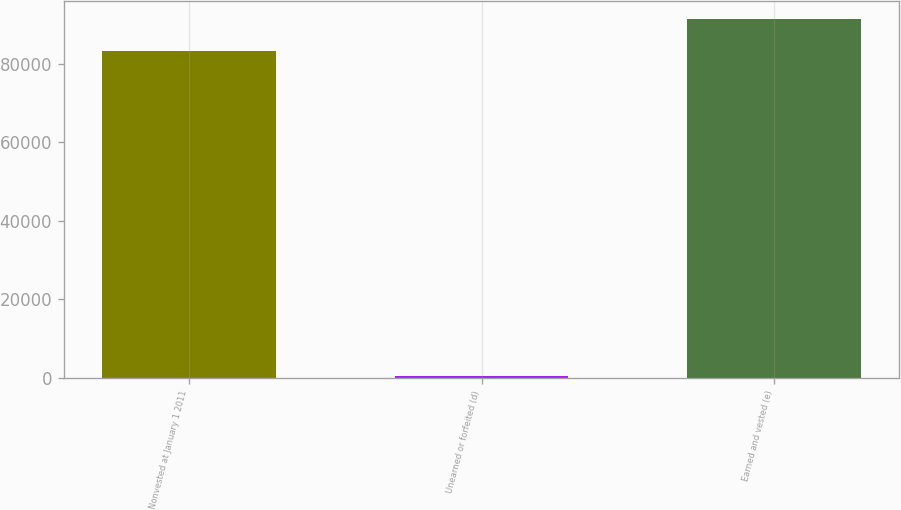Convert chart to OTSL. <chart><loc_0><loc_0><loc_500><loc_500><bar_chart><fcel>Nonvested at January 1 2011<fcel>Unearned or forfeited (d)<fcel>Earned and vested (e)<nl><fcel>83154<fcel>560<fcel>91457.9<nl></chart> 